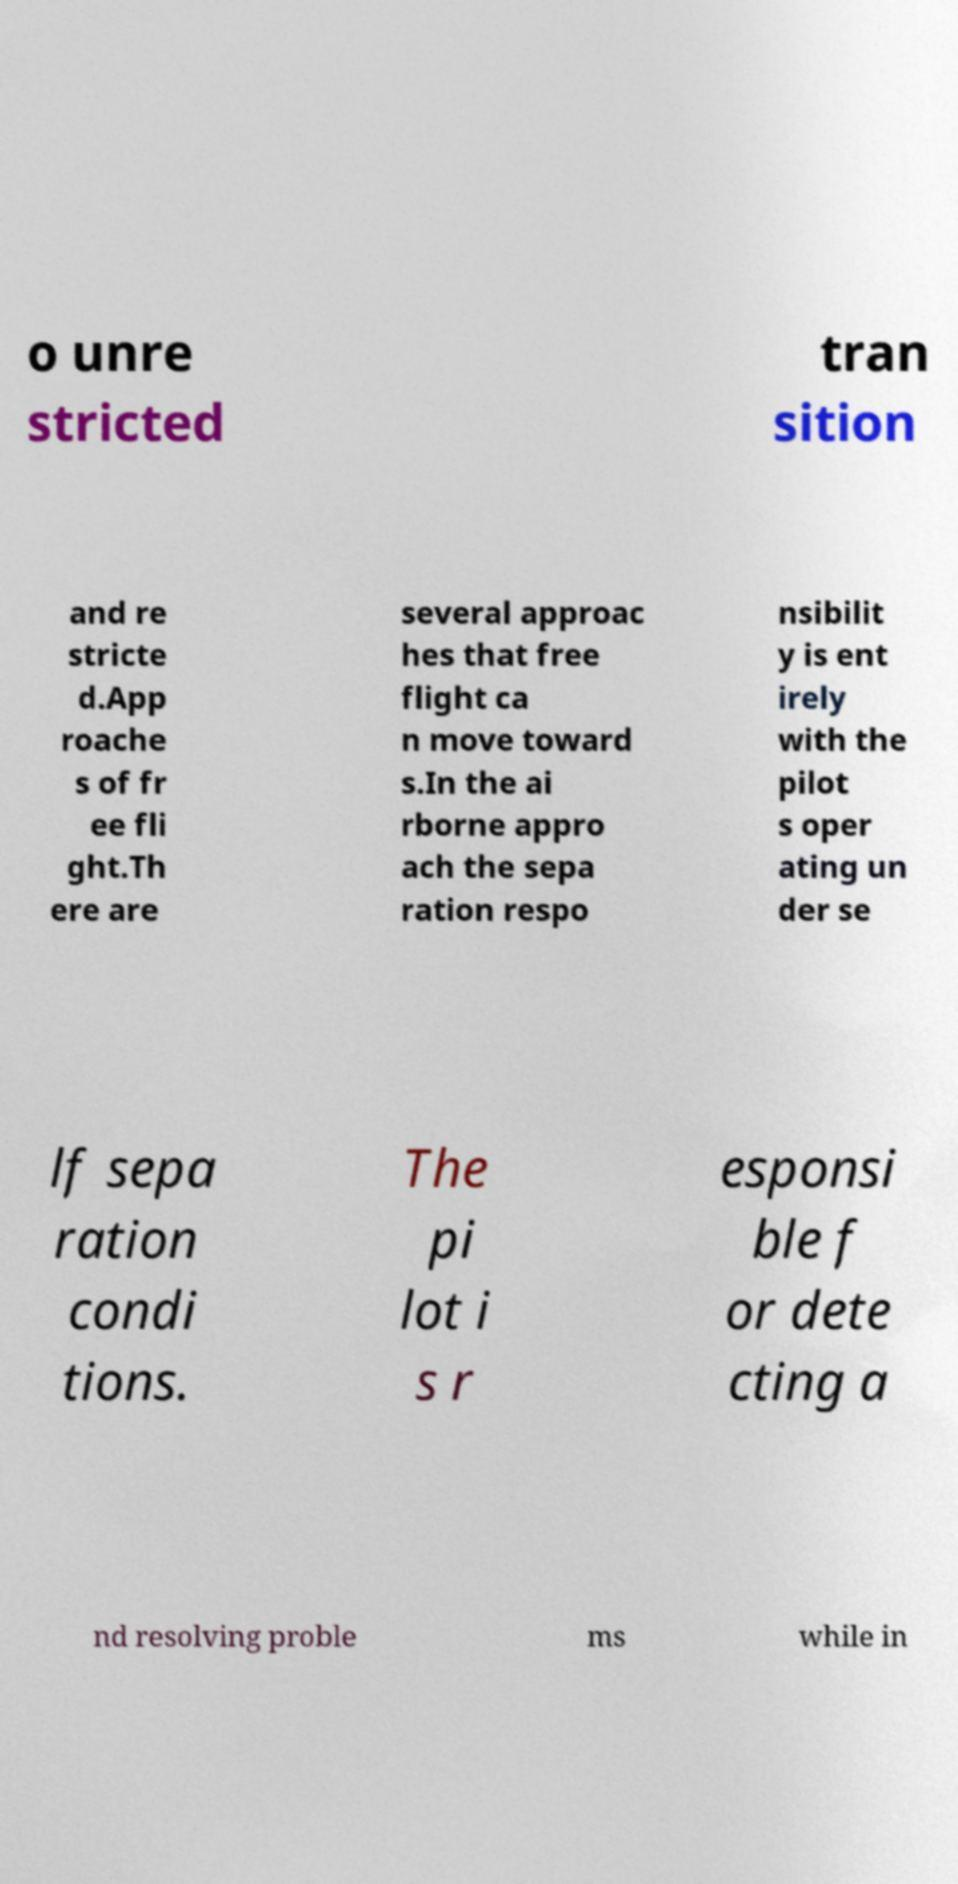Could you extract and type out the text from this image? o unre stricted tran sition and re stricte d.App roache s of fr ee fli ght.Th ere are several approac hes that free flight ca n move toward s.In the ai rborne appro ach the sepa ration respo nsibilit y is ent irely with the pilot s oper ating un der se lf sepa ration condi tions. The pi lot i s r esponsi ble f or dete cting a nd resolving proble ms while in 